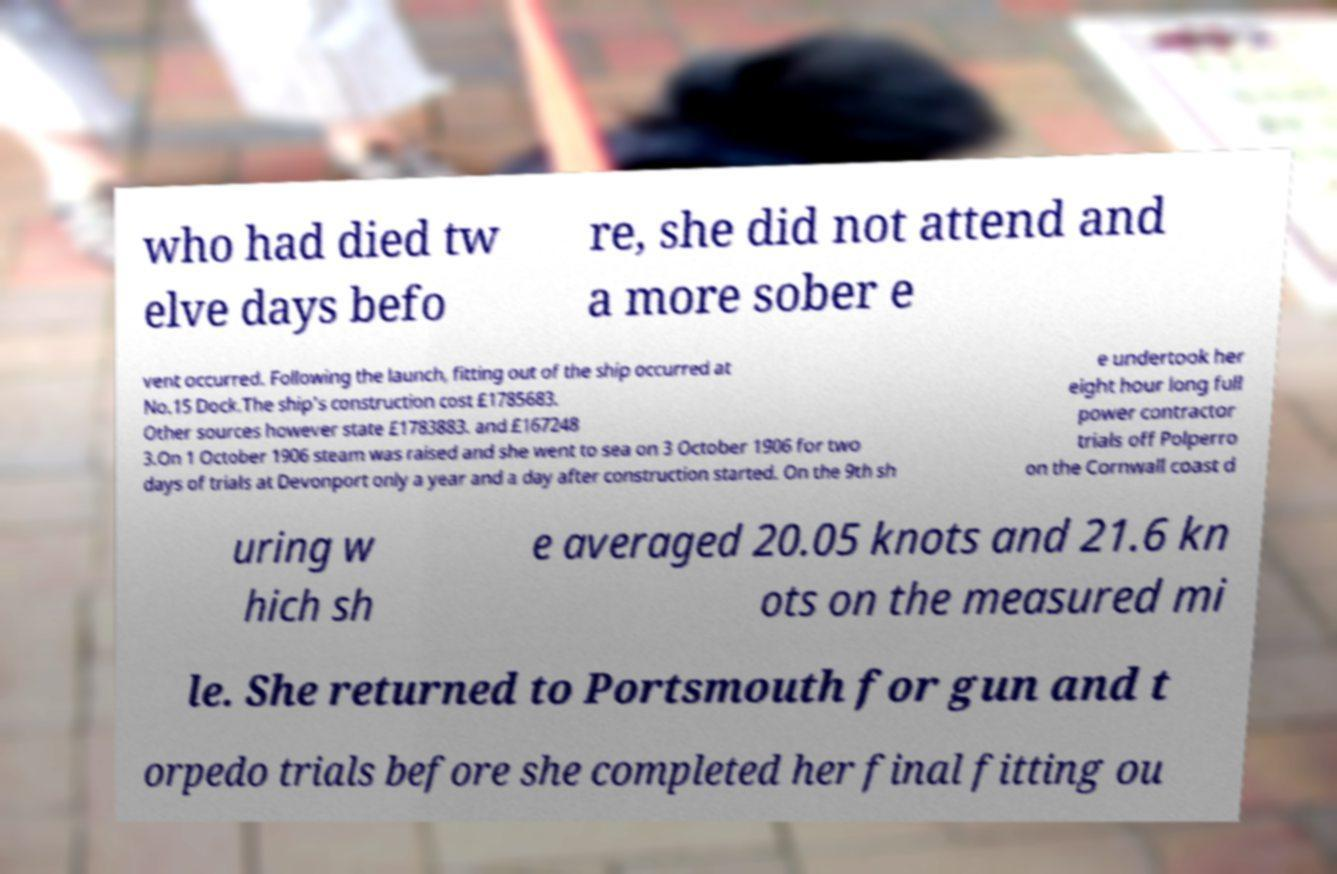Could you assist in decoding the text presented in this image and type it out clearly? who had died tw elve days befo re, she did not attend and a more sober e vent occurred. Following the launch, fitting out of the ship occurred at No.15 Dock.The ship's construction cost £1785683. Other sources however state £1783883. and £167248 3.On 1 October 1906 steam was raised and she went to sea on 3 October 1906 for two days of trials at Devonport only a year and a day after construction started. On the 9th sh e undertook her eight hour long full power contractor trials off Polperro on the Cornwall coast d uring w hich sh e averaged 20.05 knots and 21.6 kn ots on the measured mi le. She returned to Portsmouth for gun and t orpedo trials before she completed her final fitting ou 